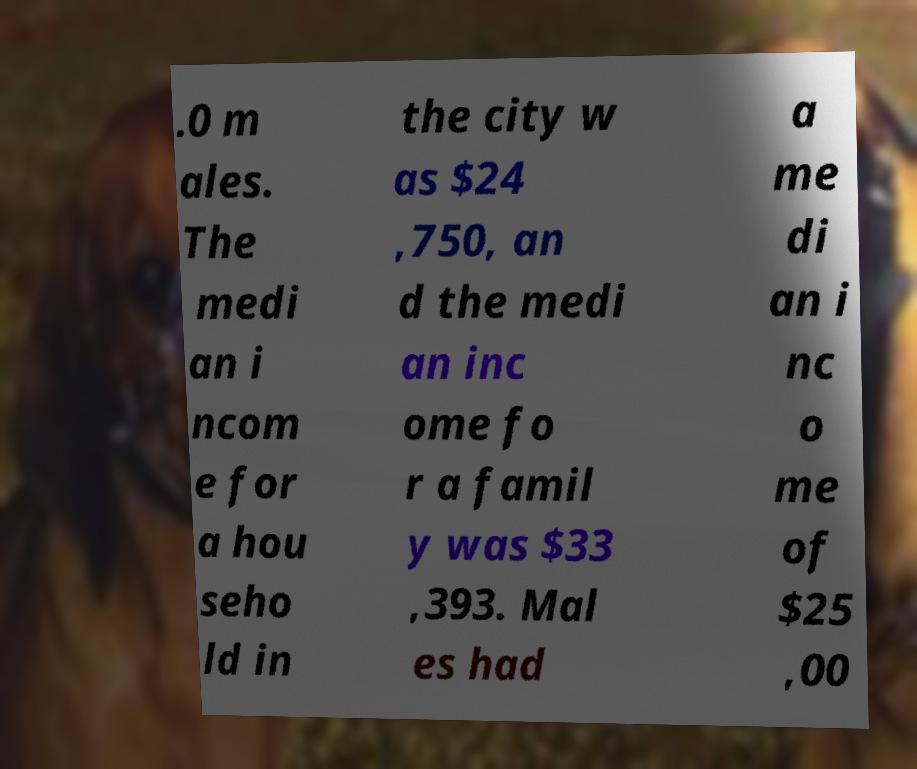There's text embedded in this image that I need extracted. Can you transcribe it verbatim? .0 m ales. The medi an i ncom e for a hou seho ld in the city w as $24 ,750, an d the medi an inc ome fo r a famil y was $33 ,393. Mal es had a me di an i nc o me of $25 ,00 